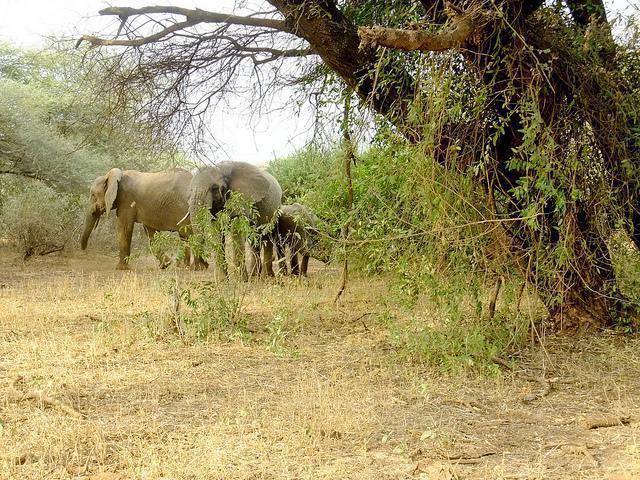How many elephants are huddled together on the left side of the hanging tree?
From the following four choices, select the correct answer to address the question.
Options: Six, five, four, three. Three. 